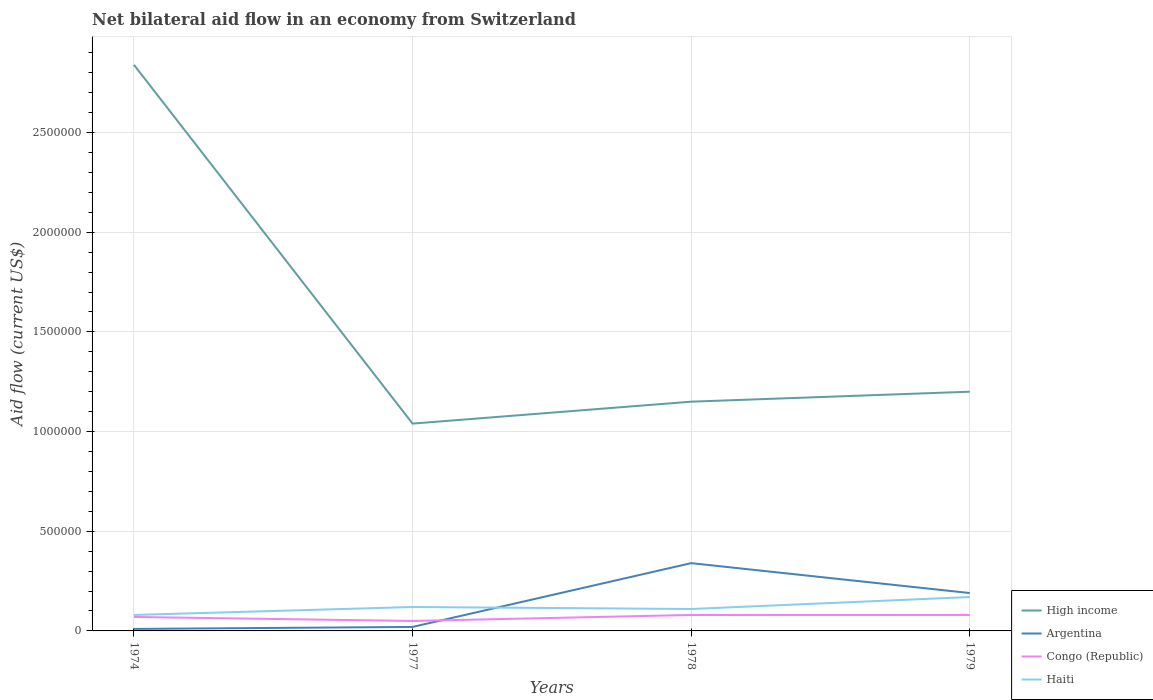Across all years, what is the maximum net bilateral aid flow in Congo (Republic)?
Offer a very short reply. 5.00e+04. In which year was the net bilateral aid flow in Haiti maximum?
Your response must be concise. 1974. What is the total net bilateral aid flow in Haiti in the graph?
Provide a short and direct response. -9.00e+04. What is the difference between the highest and the second highest net bilateral aid flow in High income?
Make the answer very short. 1.80e+06. What is the difference between the highest and the lowest net bilateral aid flow in High income?
Your response must be concise. 1. How many years are there in the graph?
Ensure brevity in your answer.  4. Are the values on the major ticks of Y-axis written in scientific E-notation?
Provide a succinct answer. No. How many legend labels are there?
Your response must be concise. 4. What is the title of the graph?
Your answer should be compact. Net bilateral aid flow in an economy from Switzerland. What is the label or title of the Y-axis?
Your response must be concise. Aid flow (current US$). What is the Aid flow (current US$) of High income in 1974?
Keep it short and to the point. 2.84e+06. What is the Aid flow (current US$) in Congo (Republic) in 1974?
Offer a terse response. 7.00e+04. What is the Aid flow (current US$) in High income in 1977?
Provide a succinct answer. 1.04e+06. What is the Aid flow (current US$) in Argentina in 1977?
Offer a very short reply. 2.00e+04. What is the Aid flow (current US$) in Congo (Republic) in 1977?
Provide a short and direct response. 5.00e+04. What is the Aid flow (current US$) in High income in 1978?
Offer a terse response. 1.15e+06. What is the Aid flow (current US$) of High income in 1979?
Your answer should be compact. 1.20e+06. What is the Aid flow (current US$) in Congo (Republic) in 1979?
Offer a terse response. 8.00e+04. What is the Aid flow (current US$) in Haiti in 1979?
Ensure brevity in your answer.  1.70e+05. Across all years, what is the maximum Aid flow (current US$) of High income?
Your answer should be very brief. 2.84e+06. Across all years, what is the maximum Aid flow (current US$) of Argentina?
Your answer should be very brief. 3.40e+05. Across all years, what is the maximum Aid flow (current US$) in Haiti?
Offer a very short reply. 1.70e+05. Across all years, what is the minimum Aid flow (current US$) of High income?
Keep it short and to the point. 1.04e+06. Across all years, what is the minimum Aid flow (current US$) of Congo (Republic)?
Give a very brief answer. 5.00e+04. What is the total Aid flow (current US$) in High income in the graph?
Your response must be concise. 6.23e+06. What is the total Aid flow (current US$) of Argentina in the graph?
Your answer should be very brief. 5.60e+05. What is the total Aid flow (current US$) in Congo (Republic) in the graph?
Ensure brevity in your answer.  2.80e+05. What is the total Aid flow (current US$) in Haiti in the graph?
Your answer should be very brief. 4.80e+05. What is the difference between the Aid flow (current US$) in High income in 1974 and that in 1977?
Keep it short and to the point. 1.80e+06. What is the difference between the Aid flow (current US$) of Argentina in 1974 and that in 1977?
Keep it short and to the point. -10000. What is the difference between the Aid flow (current US$) of Congo (Republic) in 1974 and that in 1977?
Give a very brief answer. 2.00e+04. What is the difference between the Aid flow (current US$) of Haiti in 1974 and that in 1977?
Keep it short and to the point. -4.00e+04. What is the difference between the Aid flow (current US$) of High income in 1974 and that in 1978?
Provide a succinct answer. 1.69e+06. What is the difference between the Aid flow (current US$) in Argentina in 1974 and that in 1978?
Your answer should be very brief. -3.30e+05. What is the difference between the Aid flow (current US$) of Congo (Republic) in 1974 and that in 1978?
Offer a very short reply. -10000. What is the difference between the Aid flow (current US$) of Haiti in 1974 and that in 1978?
Offer a terse response. -3.00e+04. What is the difference between the Aid flow (current US$) of High income in 1974 and that in 1979?
Provide a short and direct response. 1.64e+06. What is the difference between the Aid flow (current US$) of Argentina in 1974 and that in 1979?
Provide a short and direct response. -1.80e+05. What is the difference between the Aid flow (current US$) of Congo (Republic) in 1974 and that in 1979?
Make the answer very short. -10000. What is the difference between the Aid flow (current US$) of Haiti in 1974 and that in 1979?
Give a very brief answer. -9.00e+04. What is the difference between the Aid flow (current US$) of Argentina in 1977 and that in 1978?
Your answer should be compact. -3.20e+05. What is the difference between the Aid flow (current US$) of Congo (Republic) in 1977 and that in 1978?
Your response must be concise. -3.00e+04. What is the difference between the Aid flow (current US$) of High income in 1977 and that in 1979?
Offer a very short reply. -1.60e+05. What is the difference between the Aid flow (current US$) in Argentina in 1977 and that in 1979?
Provide a succinct answer. -1.70e+05. What is the difference between the Aid flow (current US$) in Haiti in 1977 and that in 1979?
Ensure brevity in your answer.  -5.00e+04. What is the difference between the Aid flow (current US$) of Argentina in 1978 and that in 1979?
Give a very brief answer. 1.50e+05. What is the difference between the Aid flow (current US$) in High income in 1974 and the Aid flow (current US$) in Argentina in 1977?
Provide a short and direct response. 2.82e+06. What is the difference between the Aid flow (current US$) of High income in 1974 and the Aid flow (current US$) of Congo (Republic) in 1977?
Ensure brevity in your answer.  2.79e+06. What is the difference between the Aid flow (current US$) of High income in 1974 and the Aid flow (current US$) of Haiti in 1977?
Provide a succinct answer. 2.72e+06. What is the difference between the Aid flow (current US$) in Argentina in 1974 and the Aid flow (current US$) in Haiti in 1977?
Provide a short and direct response. -1.10e+05. What is the difference between the Aid flow (current US$) of Congo (Republic) in 1974 and the Aid flow (current US$) of Haiti in 1977?
Provide a short and direct response. -5.00e+04. What is the difference between the Aid flow (current US$) in High income in 1974 and the Aid flow (current US$) in Argentina in 1978?
Offer a terse response. 2.50e+06. What is the difference between the Aid flow (current US$) of High income in 1974 and the Aid flow (current US$) of Congo (Republic) in 1978?
Ensure brevity in your answer.  2.76e+06. What is the difference between the Aid flow (current US$) in High income in 1974 and the Aid flow (current US$) in Haiti in 1978?
Ensure brevity in your answer.  2.73e+06. What is the difference between the Aid flow (current US$) in Argentina in 1974 and the Aid flow (current US$) in Congo (Republic) in 1978?
Your answer should be very brief. -7.00e+04. What is the difference between the Aid flow (current US$) in Argentina in 1974 and the Aid flow (current US$) in Haiti in 1978?
Give a very brief answer. -1.00e+05. What is the difference between the Aid flow (current US$) in Congo (Republic) in 1974 and the Aid flow (current US$) in Haiti in 1978?
Keep it short and to the point. -4.00e+04. What is the difference between the Aid flow (current US$) in High income in 1974 and the Aid flow (current US$) in Argentina in 1979?
Offer a very short reply. 2.65e+06. What is the difference between the Aid flow (current US$) in High income in 1974 and the Aid flow (current US$) in Congo (Republic) in 1979?
Ensure brevity in your answer.  2.76e+06. What is the difference between the Aid flow (current US$) in High income in 1974 and the Aid flow (current US$) in Haiti in 1979?
Ensure brevity in your answer.  2.67e+06. What is the difference between the Aid flow (current US$) of High income in 1977 and the Aid flow (current US$) of Argentina in 1978?
Provide a short and direct response. 7.00e+05. What is the difference between the Aid flow (current US$) of High income in 1977 and the Aid flow (current US$) of Congo (Republic) in 1978?
Your response must be concise. 9.60e+05. What is the difference between the Aid flow (current US$) of High income in 1977 and the Aid flow (current US$) of Haiti in 1978?
Provide a short and direct response. 9.30e+05. What is the difference between the Aid flow (current US$) in Argentina in 1977 and the Aid flow (current US$) in Haiti in 1978?
Offer a very short reply. -9.00e+04. What is the difference between the Aid flow (current US$) in High income in 1977 and the Aid flow (current US$) in Argentina in 1979?
Make the answer very short. 8.50e+05. What is the difference between the Aid flow (current US$) of High income in 1977 and the Aid flow (current US$) of Congo (Republic) in 1979?
Your answer should be compact. 9.60e+05. What is the difference between the Aid flow (current US$) in High income in 1977 and the Aid flow (current US$) in Haiti in 1979?
Provide a short and direct response. 8.70e+05. What is the difference between the Aid flow (current US$) of Argentina in 1977 and the Aid flow (current US$) of Congo (Republic) in 1979?
Offer a very short reply. -6.00e+04. What is the difference between the Aid flow (current US$) in Congo (Republic) in 1977 and the Aid flow (current US$) in Haiti in 1979?
Offer a very short reply. -1.20e+05. What is the difference between the Aid flow (current US$) in High income in 1978 and the Aid flow (current US$) in Argentina in 1979?
Your answer should be very brief. 9.60e+05. What is the difference between the Aid flow (current US$) of High income in 1978 and the Aid flow (current US$) of Congo (Republic) in 1979?
Keep it short and to the point. 1.07e+06. What is the difference between the Aid flow (current US$) in High income in 1978 and the Aid flow (current US$) in Haiti in 1979?
Give a very brief answer. 9.80e+05. What is the difference between the Aid flow (current US$) in Argentina in 1978 and the Aid flow (current US$) in Congo (Republic) in 1979?
Your answer should be very brief. 2.60e+05. What is the difference between the Aid flow (current US$) of Congo (Republic) in 1978 and the Aid flow (current US$) of Haiti in 1979?
Provide a succinct answer. -9.00e+04. What is the average Aid flow (current US$) of High income per year?
Ensure brevity in your answer.  1.56e+06. What is the average Aid flow (current US$) of Argentina per year?
Keep it short and to the point. 1.40e+05. What is the average Aid flow (current US$) of Haiti per year?
Provide a succinct answer. 1.20e+05. In the year 1974, what is the difference between the Aid flow (current US$) of High income and Aid flow (current US$) of Argentina?
Offer a very short reply. 2.83e+06. In the year 1974, what is the difference between the Aid flow (current US$) in High income and Aid flow (current US$) in Congo (Republic)?
Keep it short and to the point. 2.77e+06. In the year 1974, what is the difference between the Aid flow (current US$) in High income and Aid flow (current US$) in Haiti?
Keep it short and to the point. 2.76e+06. In the year 1974, what is the difference between the Aid flow (current US$) in Argentina and Aid flow (current US$) in Congo (Republic)?
Offer a terse response. -6.00e+04. In the year 1974, what is the difference between the Aid flow (current US$) of Argentina and Aid flow (current US$) of Haiti?
Provide a short and direct response. -7.00e+04. In the year 1974, what is the difference between the Aid flow (current US$) of Congo (Republic) and Aid flow (current US$) of Haiti?
Your answer should be very brief. -10000. In the year 1977, what is the difference between the Aid flow (current US$) of High income and Aid flow (current US$) of Argentina?
Provide a short and direct response. 1.02e+06. In the year 1977, what is the difference between the Aid flow (current US$) of High income and Aid flow (current US$) of Congo (Republic)?
Offer a very short reply. 9.90e+05. In the year 1977, what is the difference between the Aid flow (current US$) in High income and Aid flow (current US$) in Haiti?
Your answer should be compact. 9.20e+05. In the year 1977, what is the difference between the Aid flow (current US$) of Argentina and Aid flow (current US$) of Congo (Republic)?
Make the answer very short. -3.00e+04. In the year 1977, what is the difference between the Aid flow (current US$) of Argentina and Aid flow (current US$) of Haiti?
Your answer should be compact. -1.00e+05. In the year 1978, what is the difference between the Aid flow (current US$) in High income and Aid flow (current US$) in Argentina?
Provide a short and direct response. 8.10e+05. In the year 1978, what is the difference between the Aid flow (current US$) of High income and Aid flow (current US$) of Congo (Republic)?
Your answer should be very brief. 1.07e+06. In the year 1978, what is the difference between the Aid flow (current US$) in High income and Aid flow (current US$) in Haiti?
Your response must be concise. 1.04e+06. In the year 1978, what is the difference between the Aid flow (current US$) of Congo (Republic) and Aid flow (current US$) of Haiti?
Provide a short and direct response. -3.00e+04. In the year 1979, what is the difference between the Aid flow (current US$) in High income and Aid flow (current US$) in Argentina?
Your response must be concise. 1.01e+06. In the year 1979, what is the difference between the Aid flow (current US$) of High income and Aid flow (current US$) of Congo (Republic)?
Offer a very short reply. 1.12e+06. In the year 1979, what is the difference between the Aid flow (current US$) of High income and Aid flow (current US$) of Haiti?
Make the answer very short. 1.03e+06. In the year 1979, what is the difference between the Aid flow (current US$) in Congo (Republic) and Aid flow (current US$) in Haiti?
Ensure brevity in your answer.  -9.00e+04. What is the ratio of the Aid flow (current US$) of High income in 1974 to that in 1977?
Provide a succinct answer. 2.73. What is the ratio of the Aid flow (current US$) of Argentina in 1974 to that in 1977?
Provide a succinct answer. 0.5. What is the ratio of the Aid flow (current US$) of High income in 1974 to that in 1978?
Keep it short and to the point. 2.47. What is the ratio of the Aid flow (current US$) in Argentina in 1974 to that in 1978?
Offer a terse response. 0.03. What is the ratio of the Aid flow (current US$) of Congo (Republic) in 1974 to that in 1978?
Your answer should be very brief. 0.88. What is the ratio of the Aid flow (current US$) of Haiti in 1974 to that in 1978?
Your answer should be very brief. 0.73. What is the ratio of the Aid flow (current US$) of High income in 1974 to that in 1979?
Offer a very short reply. 2.37. What is the ratio of the Aid flow (current US$) of Argentina in 1974 to that in 1979?
Give a very brief answer. 0.05. What is the ratio of the Aid flow (current US$) in Haiti in 1974 to that in 1979?
Your answer should be very brief. 0.47. What is the ratio of the Aid flow (current US$) of High income in 1977 to that in 1978?
Ensure brevity in your answer.  0.9. What is the ratio of the Aid flow (current US$) of Argentina in 1977 to that in 1978?
Provide a short and direct response. 0.06. What is the ratio of the Aid flow (current US$) in Congo (Republic) in 1977 to that in 1978?
Provide a short and direct response. 0.62. What is the ratio of the Aid flow (current US$) of Haiti in 1977 to that in 1978?
Your answer should be very brief. 1.09. What is the ratio of the Aid flow (current US$) of High income in 1977 to that in 1979?
Provide a short and direct response. 0.87. What is the ratio of the Aid flow (current US$) of Argentina in 1977 to that in 1979?
Provide a short and direct response. 0.11. What is the ratio of the Aid flow (current US$) in Congo (Republic) in 1977 to that in 1979?
Your answer should be compact. 0.62. What is the ratio of the Aid flow (current US$) of Haiti in 1977 to that in 1979?
Provide a succinct answer. 0.71. What is the ratio of the Aid flow (current US$) of Argentina in 1978 to that in 1979?
Your answer should be compact. 1.79. What is the ratio of the Aid flow (current US$) of Haiti in 1978 to that in 1979?
Your answer should be very brief. 0.65. What is the difference between the highest and the second highest Aid flow (current US$) of High income?
Offer a terse response. 1.64e+06. What is the difference between the highest and the second highest Aid flow (current US$) in Haiti?
Offer a very short reply. 5.00e+04. What is the difference between the highest and the lowest Aid flow (current US$) in High income?
Offer a very short reply. 1.80e+06. What is the difference between the highest and the lowest Aid flow (current US$) of Congo (Republic)?
Your answer should be very brief. 3.00e+04. What is the difference between the highest and the lowest Aid flow (current US$) in Haiti?
Offer a terse response. 9.00e+04. 